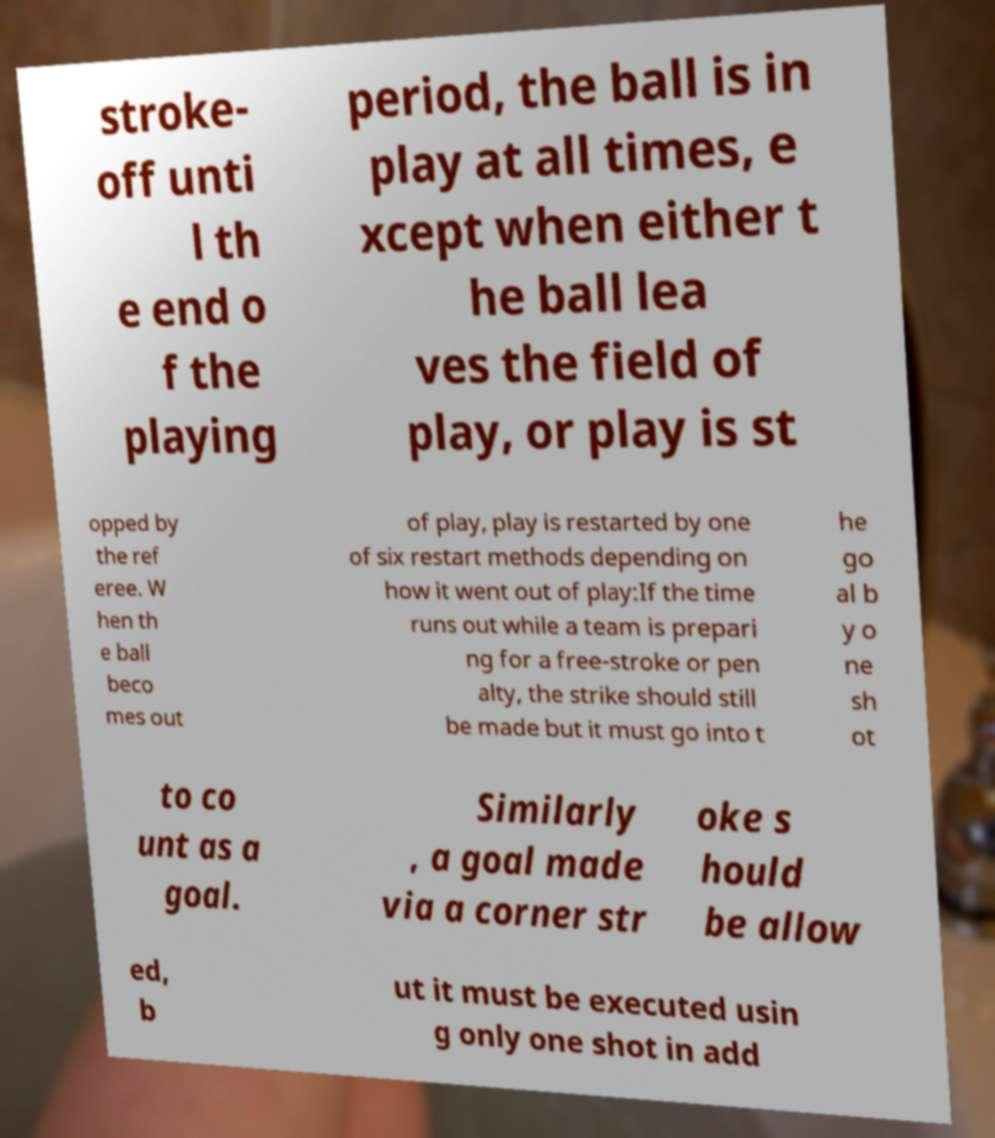Please read and relay the text visible in this image. What does it say? stroke- off unti l th e end o f the playing period, the ball is in play at all times, e xcept when either t he ball lea ves the field of play, or play is st opped by the ref eree. W hen th e ball beco mes out of play, play is restarted by one of six restart methods depending on how it went out of play:If the time runs out while a team is prepari ng for a free-stroke or pen alty, the strike should still be made but it must go into t he go al b y o ne sh ot to co unt as a goal. Similarly , a goal made via a corner str oke s hould be allow ed, b ut it must be executed usin g only one shot in add 